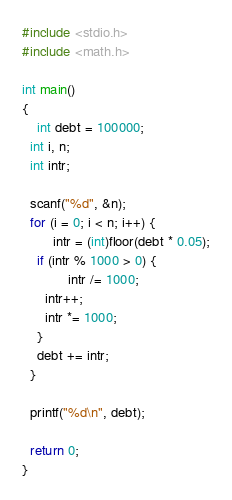<code> <loc_0><loc_0><loc_500><loc_500><_C_>#include <stdio.h>
#include <math.h>

int main()
{
	int debt = 100000;
  int i, n;
  int intr;

  scanf("%d", &n);
  for (i = 0; i < n; i++) {
		intr = (int)floor(debt * 0.05);
    if (intr % 1000 > 0) {
			intr /= 1000;
      intr++;
      intr *= 1000;
    }
    debt += intr;
  }

  printf("%d\n", debt);

  return 0;
}</code> 